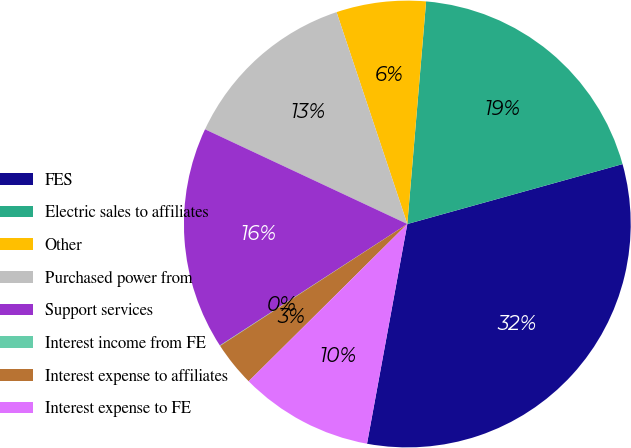Convert chart. <chart><loc_0><loc_0><loc_500><loc_500><pie_chart><fcel>FES<fcel>Electric sales to affiliates<fcel>Other<fcel>Purchased power from<fcel>Support services<fcel>Interest income from FE<fcel>Interest expense to affiliates<fcel>Interest expense to FE<nl><fcel>32.21%<fcel>19.34%<fcel>6.47%<fcel>12.9%<fcel>16.12%<fcel>0.03%<fcel>3.25%<fcel>9.68%<nl></chart> 